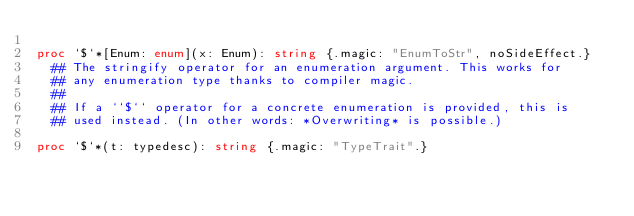<code> <loc_0><loc_0><loc_500><loc_500><_Nim_>
proc `$`*[Enum: enum](x: Enum): string {.magic: "EnumToStr", noSideEffect.}
  ## The stringify operator for an enumeration argument. This works for
  ## any enumeration type thanks to compiler magic.
  ##
  ## If a ``$`` operator for a concrete enumeration is provided, this is
  ## used instead. (In other words: *Overwriting* is possible.)

proc `$`*(t: typedesc): string {.magic: "TypeTrait".}</code> 